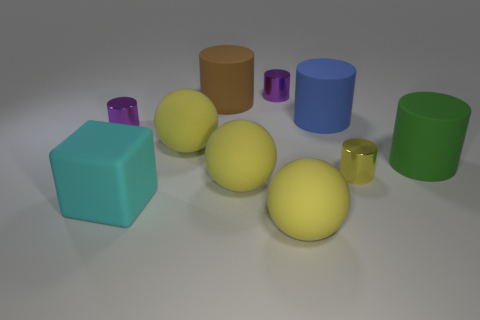How many other objects are the same size as the cyan cube?
Give a very brief answer. 6. Is there any other thing that has the same shape as the big blue rubber thing?
Keep it short and to the point. Yes. Is the number of rubber objects on the right side of the large blue matte cylinder the same as the number of brown matte cylinders?
Offer a very short reply. Yes. How many brown objects have the same material as the big block?
Give a very brief answer. 1. There is a large block that is made of the same material as the blue thing; what color is it?
Your response must be concise. Cyan. Do the large blue object and the tiny yellow thing have the same shape?
Your answer should be very brief. Yes. Are there any yellow matte things in front of the yellow thing to the right of the big matte object that is in front of the big rubber block?
Provide a succinct answer. Yes. How many big matte cylinders have the same color as the rubber cube?
Offer a terse response. 0. What is the shape of the brown thing that is the same size as the cube?
Ensure brevity in your answer.  Cylinder. Are there any cyan objects behind the small yellow shiny cylinder?
Ensure brevity in your answer.  No. 